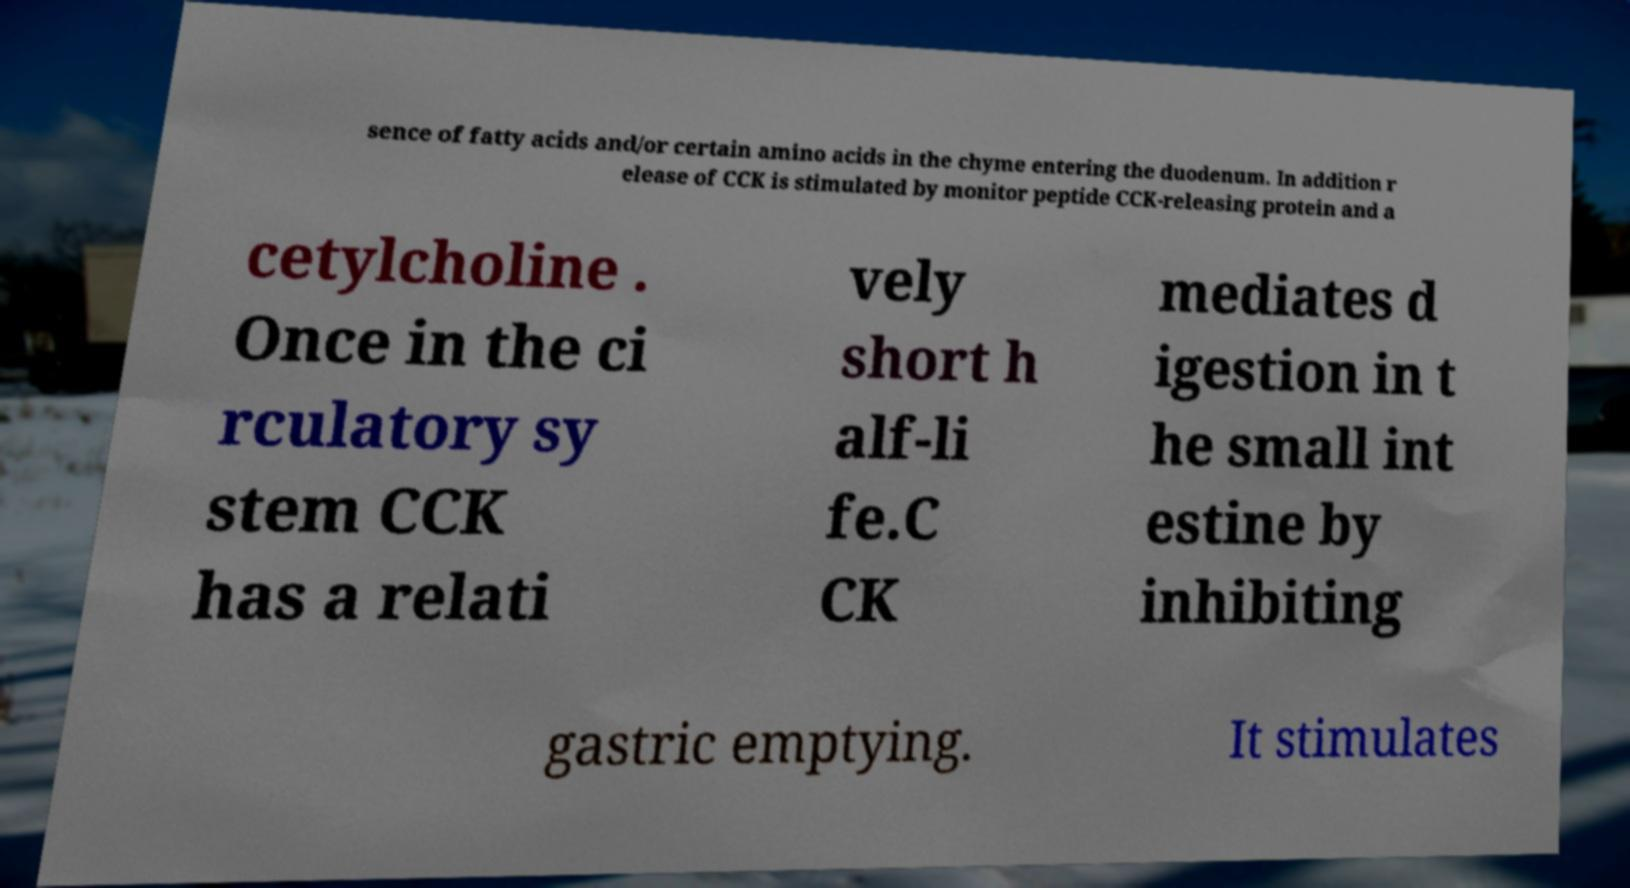For documentation purposes, I need the text within this image transcribed. Could you provide that? sence of fatty acids and/or certain amino acids in the chyme entering the duodenum. In addition r elease of CCK is stimulated by monitor peptide CCK-releasing protein and a cetylcholine . Once in the ci rculatory sy stem CCK has a relati vely short h alf-li fe.C CK mediates d igestion in t he small int estine by inhibiting gastric emptying. It stimulates 